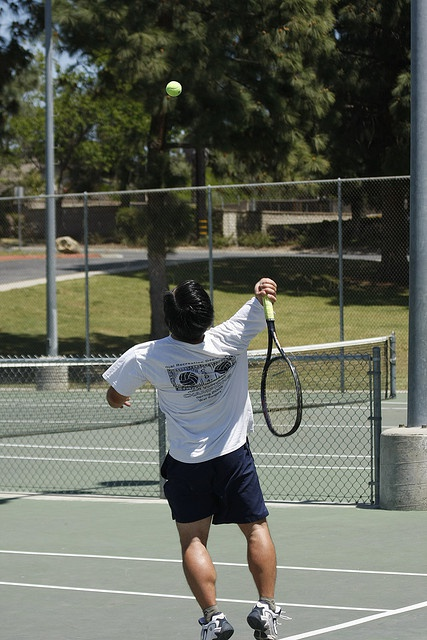Describe the objects in this image and their specific colors. I can see people in gray, black, and lightgray tones, tennis racket in gray, darkgray, and black tones, and sports ball in gray, khaki, lightyellow, olive, and lightgreen tones in this image. 